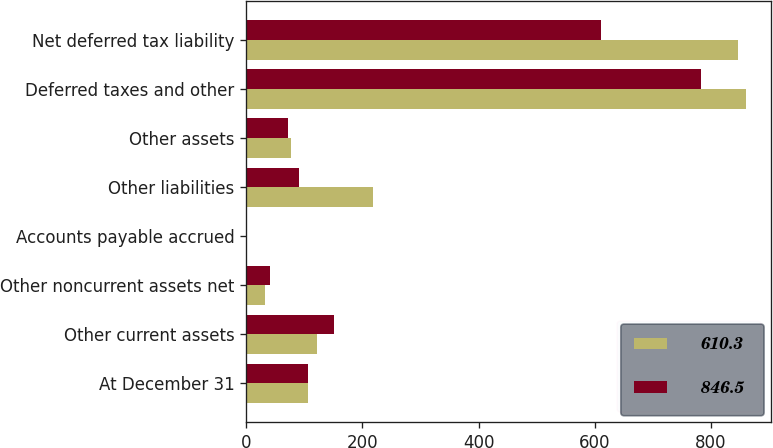<chart> <loc_0><loc_0><loc_500><loc_500><stacked_bar_chart><ecel><fcel>At December 31<fcel>Other current assets<fcel>Other noncurrent assets net<fcel>Accounts payable accrued<fcel>Other liabilities<fcel>Other assets<fcel>Deferred taxes and other<fcel>Net deferred tax liability<nl><fcel>610.3<fcel>106.45<fcel>122.2<fcel>33.1<fcel>0.6<fcel>218.7<fcel>77.2<fcel>859.7<fcel>846.5<nl><fcel>846.5<fcel>106.45<fcel>151.2<fcel>40.9<fcel>1.7<fcel>90.7<fcel>72.4<fcel>782.4<fcel>610.3<nl></chart> 